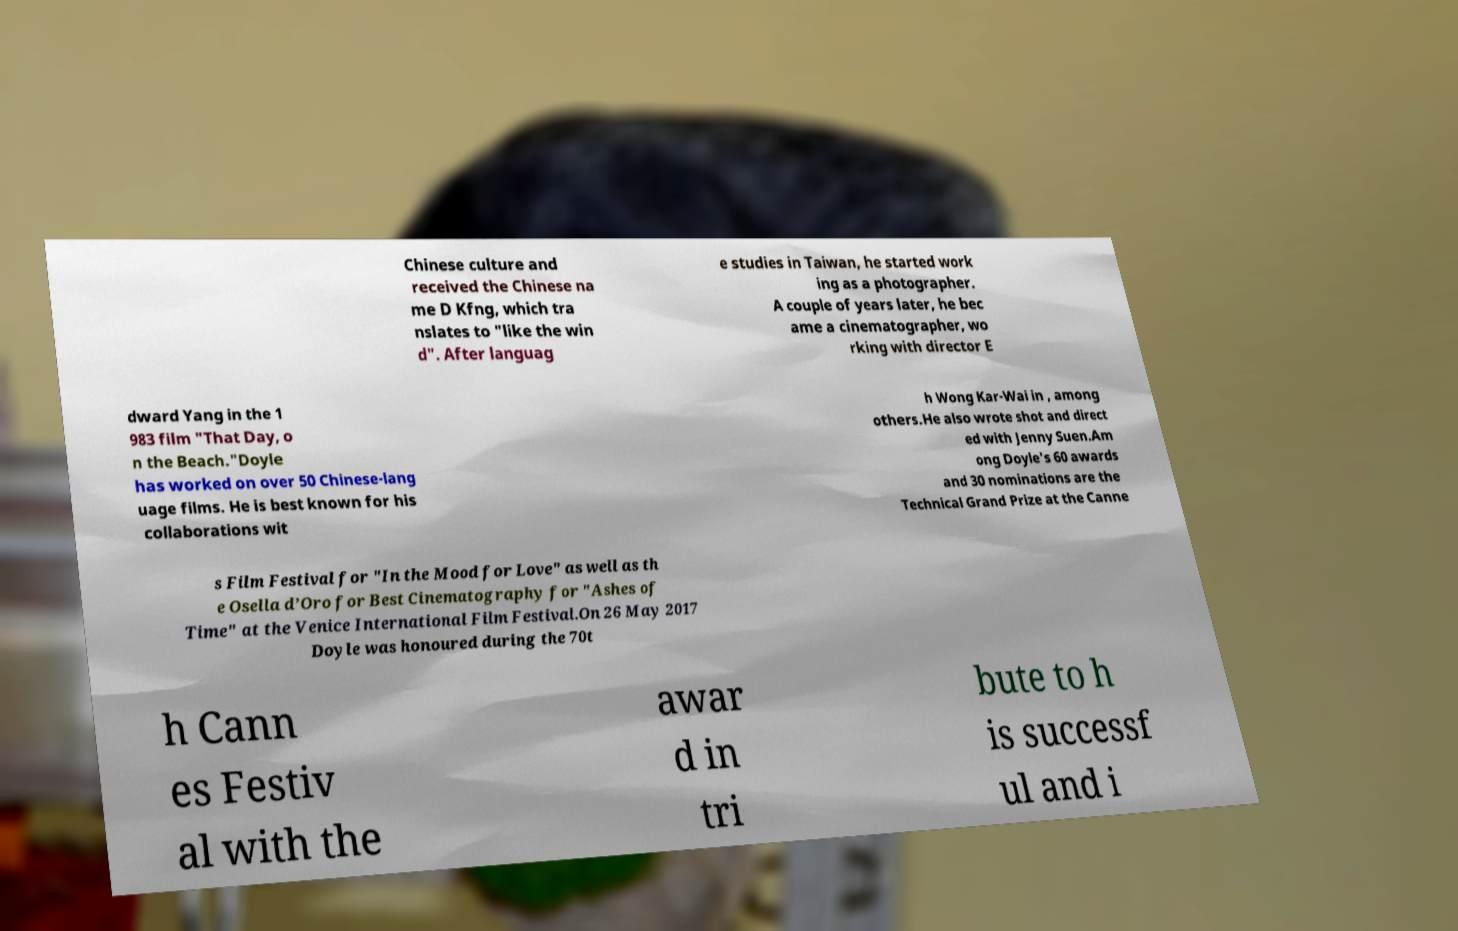Could you assist in decoding the text presented in this image and type it out clearly? Chinese culture and received the Chinese na me D Kfng, which tra nslates to "like the win d". After languag e studies in Taiwan, he started work ing as a photographer. A couple of years later, he bec ame a cinematographer, wo rking with director E dward Yang in the 1 983 film "That Day, o n the Beach."Doyle has worked on over 50 Chinese-lang uage films. He is best known for his collaborations wit h Wong Kar-Wai in , among others.He also wrote shot and direct ed with Jenny Suen.Am ong Doyle's 60 awards and 30 nominations are the Technical Grand Prize at the Canne s Film Festival for "In the Mood for Love" as well as th e Osella d’Oro for Best Cinematography for "Ashes of Time" at the Venice International Film Festival.On 26 May 2017 Doyle was honoured during the 70t h Cann es Festiv al with the awar d in tri bute to h is successf ul and i 